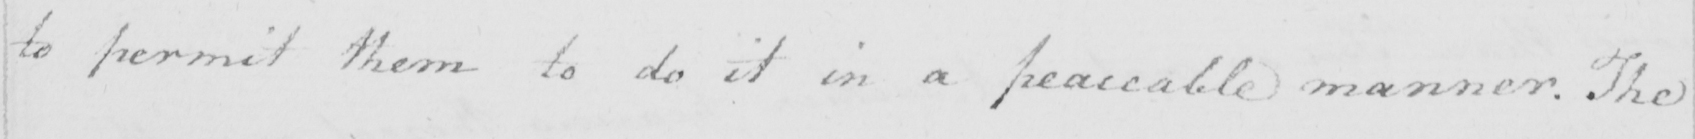Transcribe the text shown in this historical manuscript line. to permit them to do it in a peaceable manner . The 